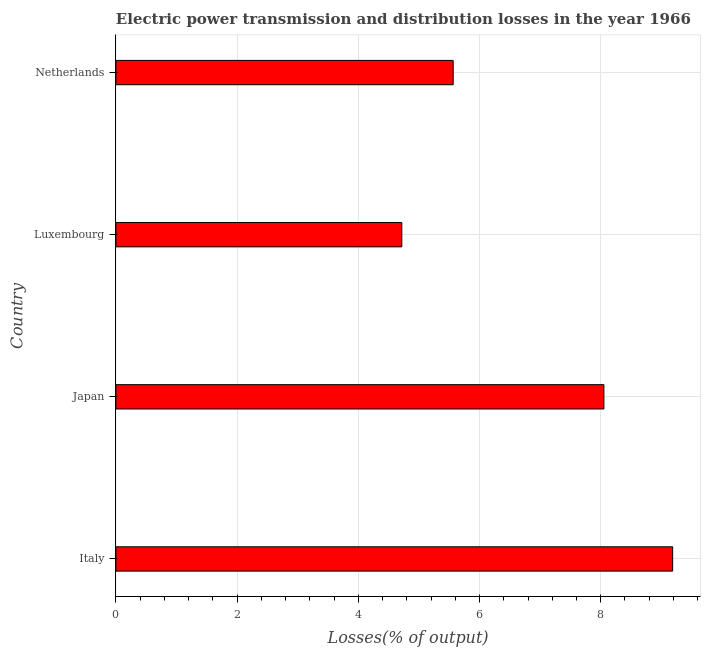Does the graph contain grids?
Offer a terse response. Yes. What is the title of the graph?
Provide a short and direct response. Electric power transmission and distribution losses in the year 1966. What is the label or title of the X-axis?
Offer a very short reply. Losses(% of output). What is the electric power transmission and distribution losses in Japan?
Ensure brevity in your answer.  8.05. Across all countries, what is the maximum electric power transmission and distribution losses?
Make the answer very short. 9.19. Across all countries, what is the minimum electric power transmission and distribution losses?
Ensure brevity in your answer.  4.72. In which country was the electric power transmission and distribution losses minimum?
Ensure brevity in your answer.  Luxembourg. What is the sum of the electric power transmission and distribution losses?
Make the answer very short. 27.52. What is the difference between the electric power transmission and distribution losses in Italy and Netherlands?
Provide a short and direct response. 3.62. What is the average electric power transmission and distribution losses per country?
Your answer should be compact. 6.88. What is the median electric power transmission and distribution losses?
Your response must be concise. 6.81. In how many countries, is the electric power transmission and distribution losses greater than 7.2 %?
Keep it short and to the point. 2. What is the ratio of the electric power transmission and distribution losses in Luxembourg to that in Netherlands?
Your response must be concise. 0.85. Is the electric power transmission and distribution losses in Italy less than that in Japan?
Give a very brief answer. No. What is the difference between the highest and the second highest electric power transmission and distribution losses?
Your answer should be very brief. 1.13. What is the difference between the highest and the lowest electric power transmission and distribution losses?
Make the answer very short. 4.47. In how many countries, is the electric power transmission and distribution losses greater than the average electric power transmission and distribution losses taken over all countries?
Offer a very short reply. 2. Are all the bars in the graph horizontal?
Your answer should be very brief. Yes. Are the values on the major ticks of X-axis written in scientific E-notation?
Provide a succinct answer. No. What is the Losses(% of output) of Italy?
Your response must be concise. 9.19. What is the Losses(% of output) of Japan?
Ensure brevity in your answer.  8.05. What is the Losses(% of output) of Luxembourg?
Offer a terse response. 4.72. What is the Losses(% of output) in Netherlands?
Give a very brief answer. 5.57. What is the difference between the Losses(% of output) in Italy and Japan?
Offer a very short reply. 1.13. What is the difference between the Losses(% of output) in Italy and Luxembourg?
Your response must be concise. 4.47. What is the difference between the Losses(% of output) in Italy and Netherlands?
Your answer should be very brief. 3.62. What is the difference between the Losses(% of output) in Japan and Luxembourg?
Give a very brief answer. 3.33. What is the difference between the Losses(% of output) in Japan and Netherlands?
Offer a terse response. 2.49. What is the difference between the Losses(% of output) in Luxembourg and Netherlands?
Keep it short and to the point. -0.85. What is the ratio of the Losses(% of output) in Italy to that in Japan?
Make the answer very short. 1.14. What is the ratio of the Losses(% of output) in Italy to that in Luxembourg?
Keep it short and to the point. 1.95. What is the ratio of the Losses(% of output) in Italy to that in Netherlands?
Provide a succinct answer. 1.65. What is the ratio of the Losses(% of output) in Japan to that in Luxembourg?
Keep it short and to the point. 1.71. What is the ratio of the Losses(% of output) in Japan to that in Netherlands?
Make the answer very short. 1.45. What is the ratio of the Losses(% of output) in Luxembourg to that in Netherlands?
Offer a terse response. 0.85. 